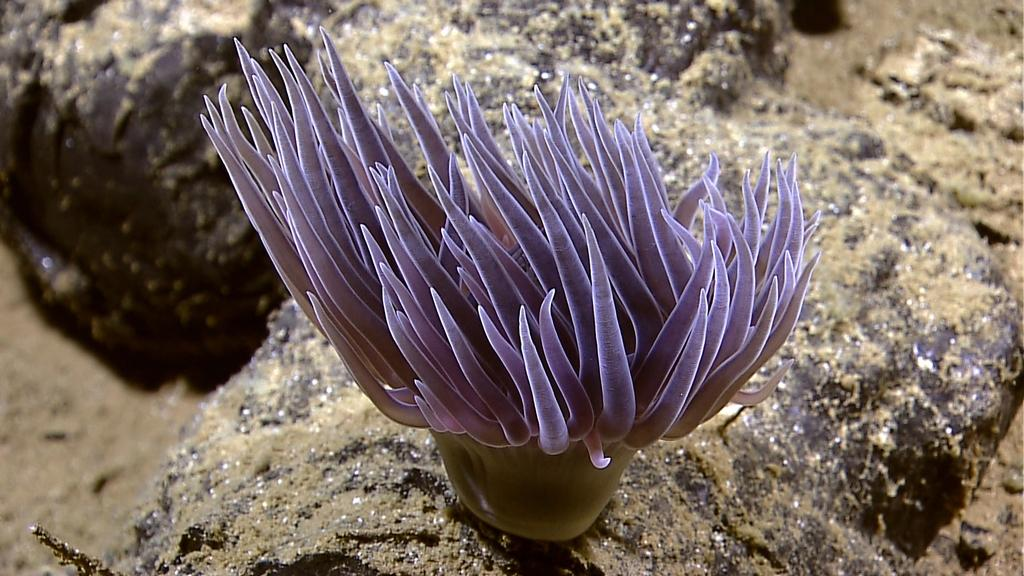What type of plant is in the image? There is a marine plant in the image. What else can be seen in the image besides the marine plant? Rocks are visible in the image. Is there any part of the image that is not clear? Yes, a part of the image is blurred. How does the wind affect the marine plant in the image? There is no wind present in the image, so its effect on the marine plant cannot be determined. 